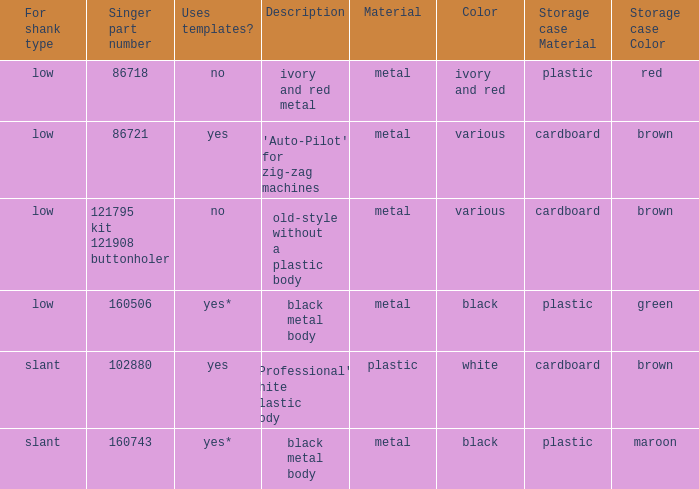What's the shank type of the buttonholer with red plastic box as storage case? Low. 